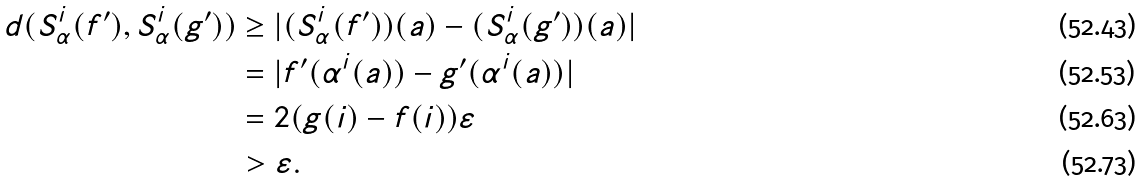Convert formula to latex. <formula><loc_0><loc_0><loc_500><loc_500>d ( S ^ { i } _ { \alpha } ( f ^ { \prime } ) , S ^ { i } _ { \alpha } ( g ^ { \prime } ) ) & \geq | ( S ^ { i } _ { \alpha } ( f ^ { \prime } ) ) ( a ) - ( S ^ { i } _ { \alpha } ( g ^ { \prime } ) ) ( a ) | \\ & = | f ^ { \prime } ( \alpha ^ { i } ( a ) ) - g ^ { \prime } ( \alpha ^ { i } ( a ) ) | \\ & = 2 ( g ( i ) - f ( i ) ) \varepsilon \\ & > \varepsilon .</formula> 